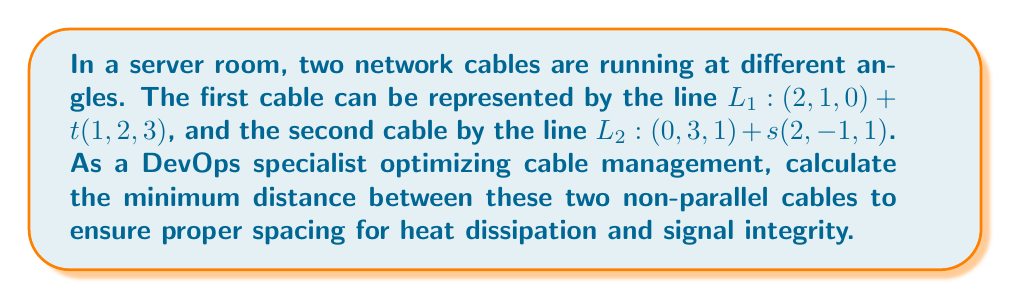What is the answer to this math problem? To find the minimum distance between two skew lines (non-parallel, non-intersecting lines), we can follow these steps:

1. Let's define the direction vectors of the lines:
   $\vec{a} = (1, 2, 3)$ for $L_1$
   $\vec{b} = (2, -1, 1)$ for $L_2$

2. Calculate the cross product of these direction vectors:
   $\vec{n} = \vec{a} \times \vec{b} = (5, 5, -5)$

3. Find a point on each line:
   $P_1 = (2, 1, 0)$ on $L_1$
   $P_2 = (0, 3, 1)$ on $L_2$

4. Calculate the vector between these points:
   $\vec{P_1P_2} = P_2 - P_1 = (-2, 2, 1)$

5. The minimum distance is given by the formula:
   $$d = \frac{|\vec{P_1P_2} \cdot \vec{n}|}{|\vec{n}|}$$

6. Calculate the dot product in the numerator:
   $\vec{P_1P_2} \cdot \vec{n} = (-2)(5) + (2)(5) + (1)(-5) = -5$

7. Calculate the magnitude of $\vec{n}$:
   $|\vec{n}| = \sqrt{5^2 + 5^2 + (-5)^2} = 5\sqrt{3}$

8. Now we can compute the minimum distance:
   $$d = \frac{|-5|}{5\sqrt{3}} = \frac{1}{\sqrt{3}}$$

[asy]
import three;
size(200);
currentprojection=perspective(6,3,2);

draw((0,0,0)--(3,6,9),blue);
draw((0,3,1)--(4,1,3),red);

dot((2,1,0),blue);
dot((0,3,1),red);

label("$L_1$",(3,6,9),NE,blue);
label("$L_2$",(4,1,3),SE,red);
label("$P_1$",(2,1,0),NW,blue);
label("$P_2$",(0,3,1),SW,red);
[/asy]
Answer: The minimum distance between the two network cables is $\frac{1}{\sqrt{3}}$ units. 